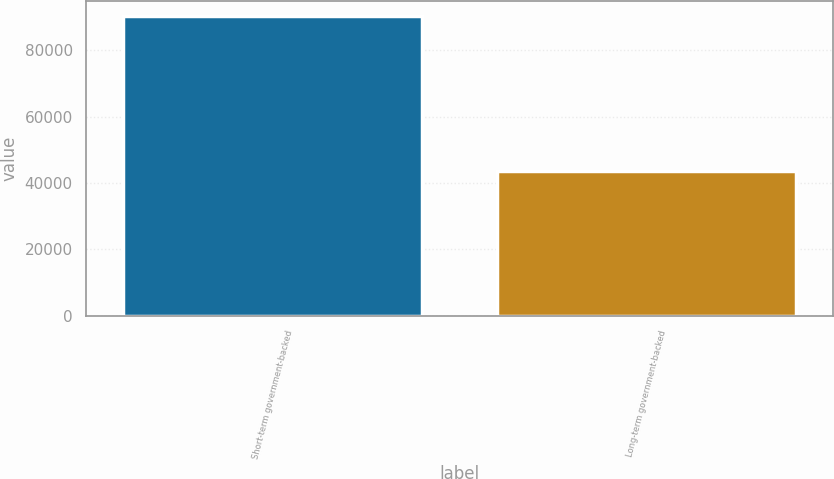Convert chart to OTSL. <chart><loc_0><loc_0><loc_500><loc_500><bar_chart><fcel>Short-term government-backed<fcel>Long-term government-backed<nl><fcel>90113<fcel>43471<nl></chart> 